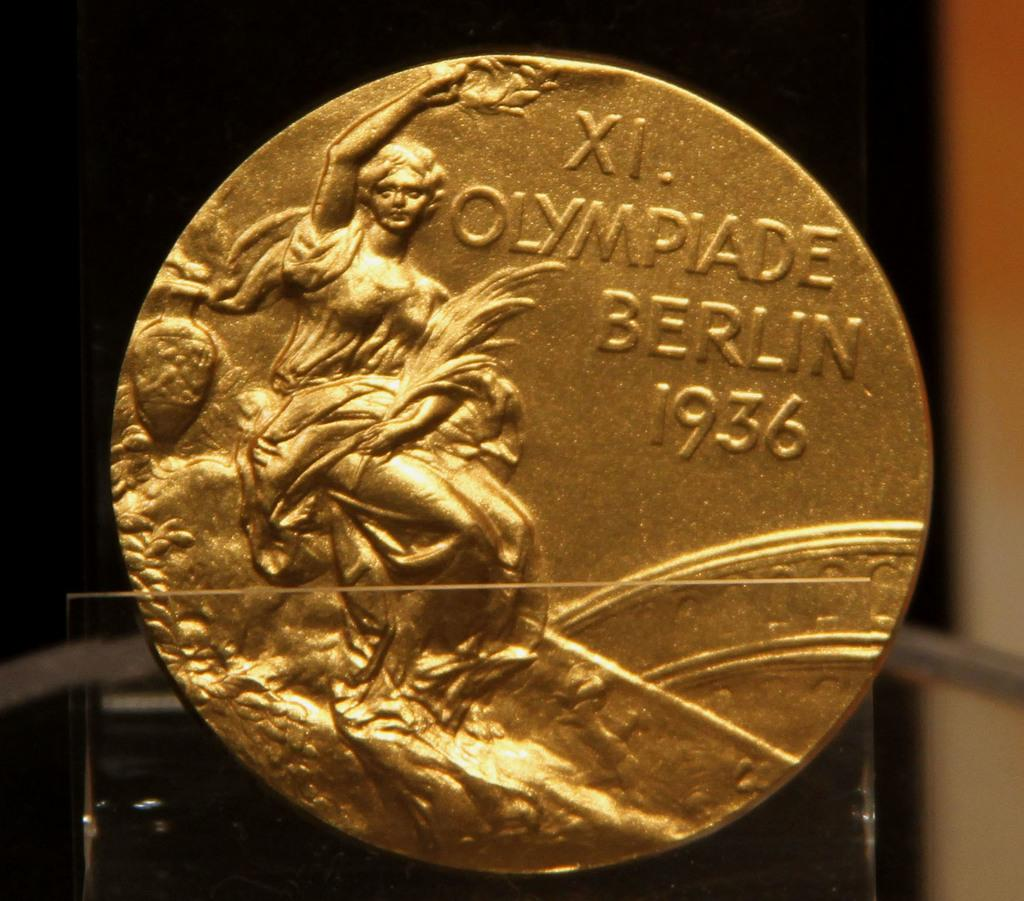<image>
Render a clear and concise summary of the photo. A coin that reads Olympiade Berlin dated 1936 